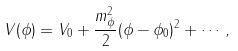<formula> <loc_0><loc_0><loc_500><loc_500>V ( \phi ) = V _ { 0 } + \frac { m _ { \phi } ^ { 2 } } { 2 } ( \phi - \phi _ { 0 } ) ^ { 2 } + \cdots \, ,</formula> 